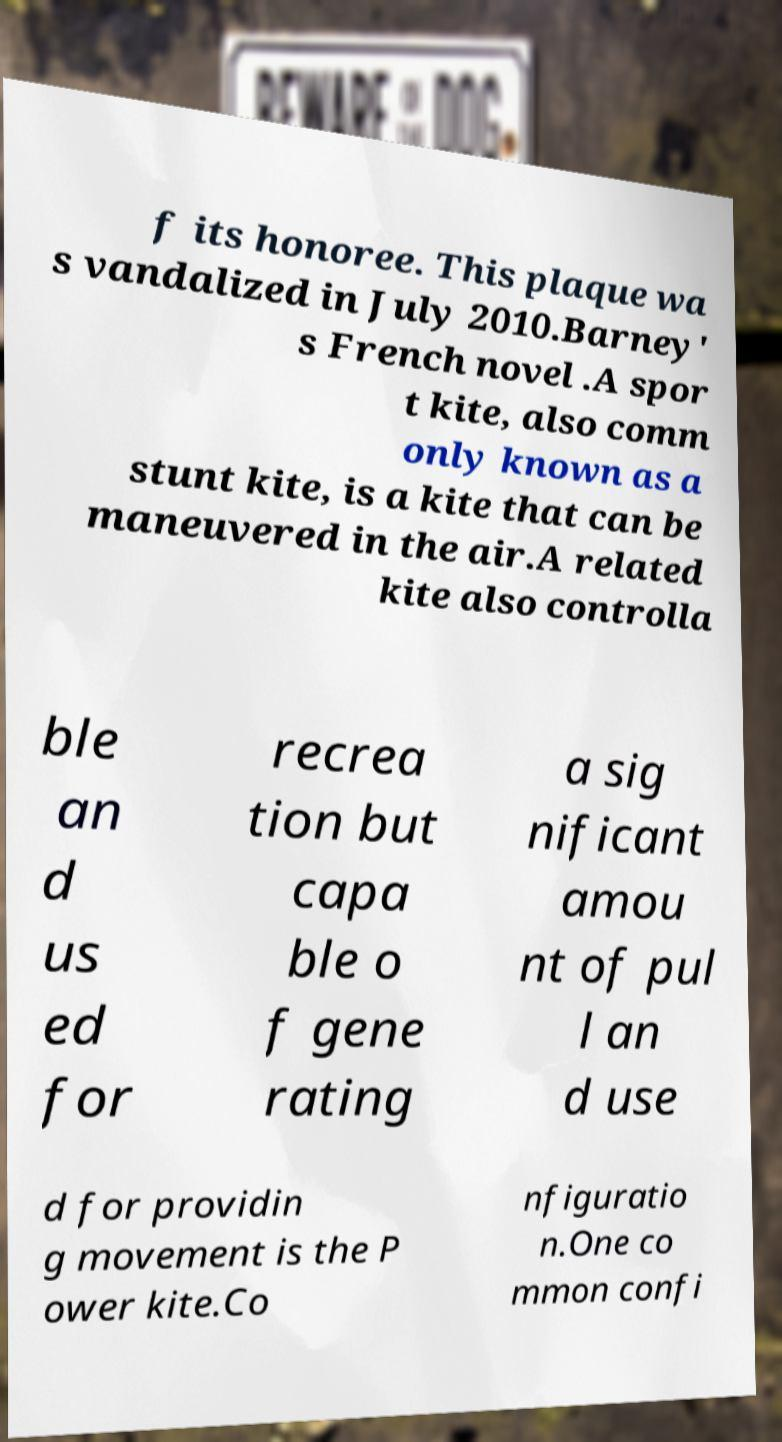There's text embedded in this image that I need extracted. Can you transcribe it verbatim? f its honoree. This plaque wa s vandalized in July 2010.Barney' s French novel .A spor t kite, also comm only known as a stunt kite, is a kite that can be maneuvered in the air.A related kite also controlla ble an d us ed for recrea tion but capa ble o f gene rating a sig nificant amou nt of pul l an d use d for providin g movement is the P ower kite.Co nfiguratio n.One co mmon confi 